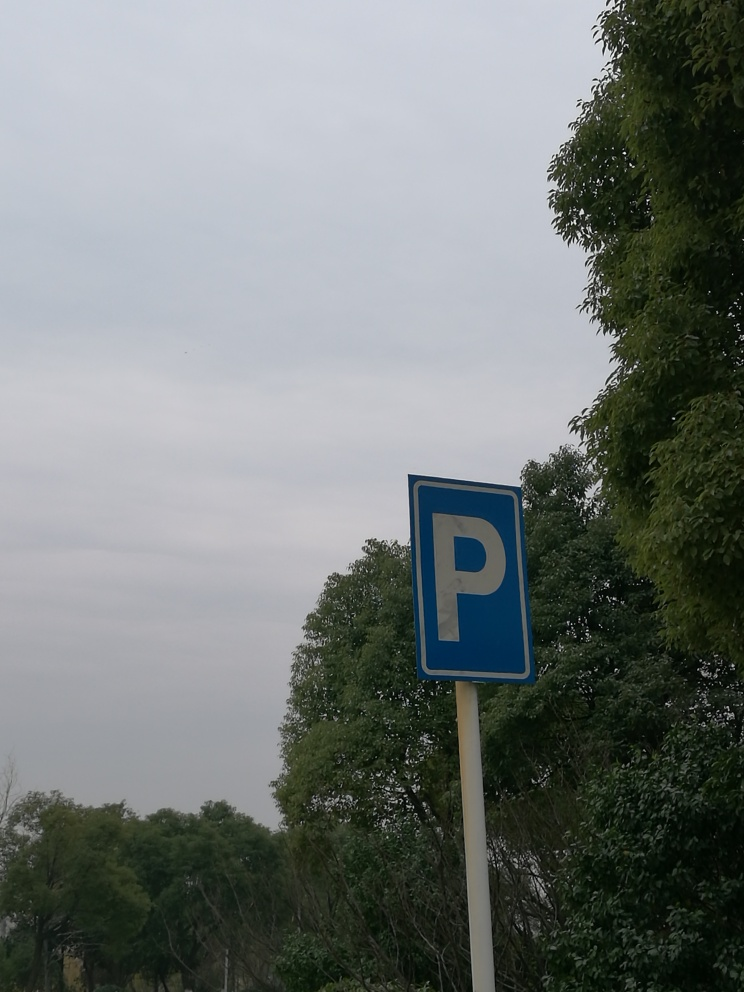Is there any distortion in the image? Upon examination, the image displays no signs of distortion. It depicts a parking sign 'P' with clarity and proper perspective, and there's no visible manipulation affecting the integrity of the scene. 